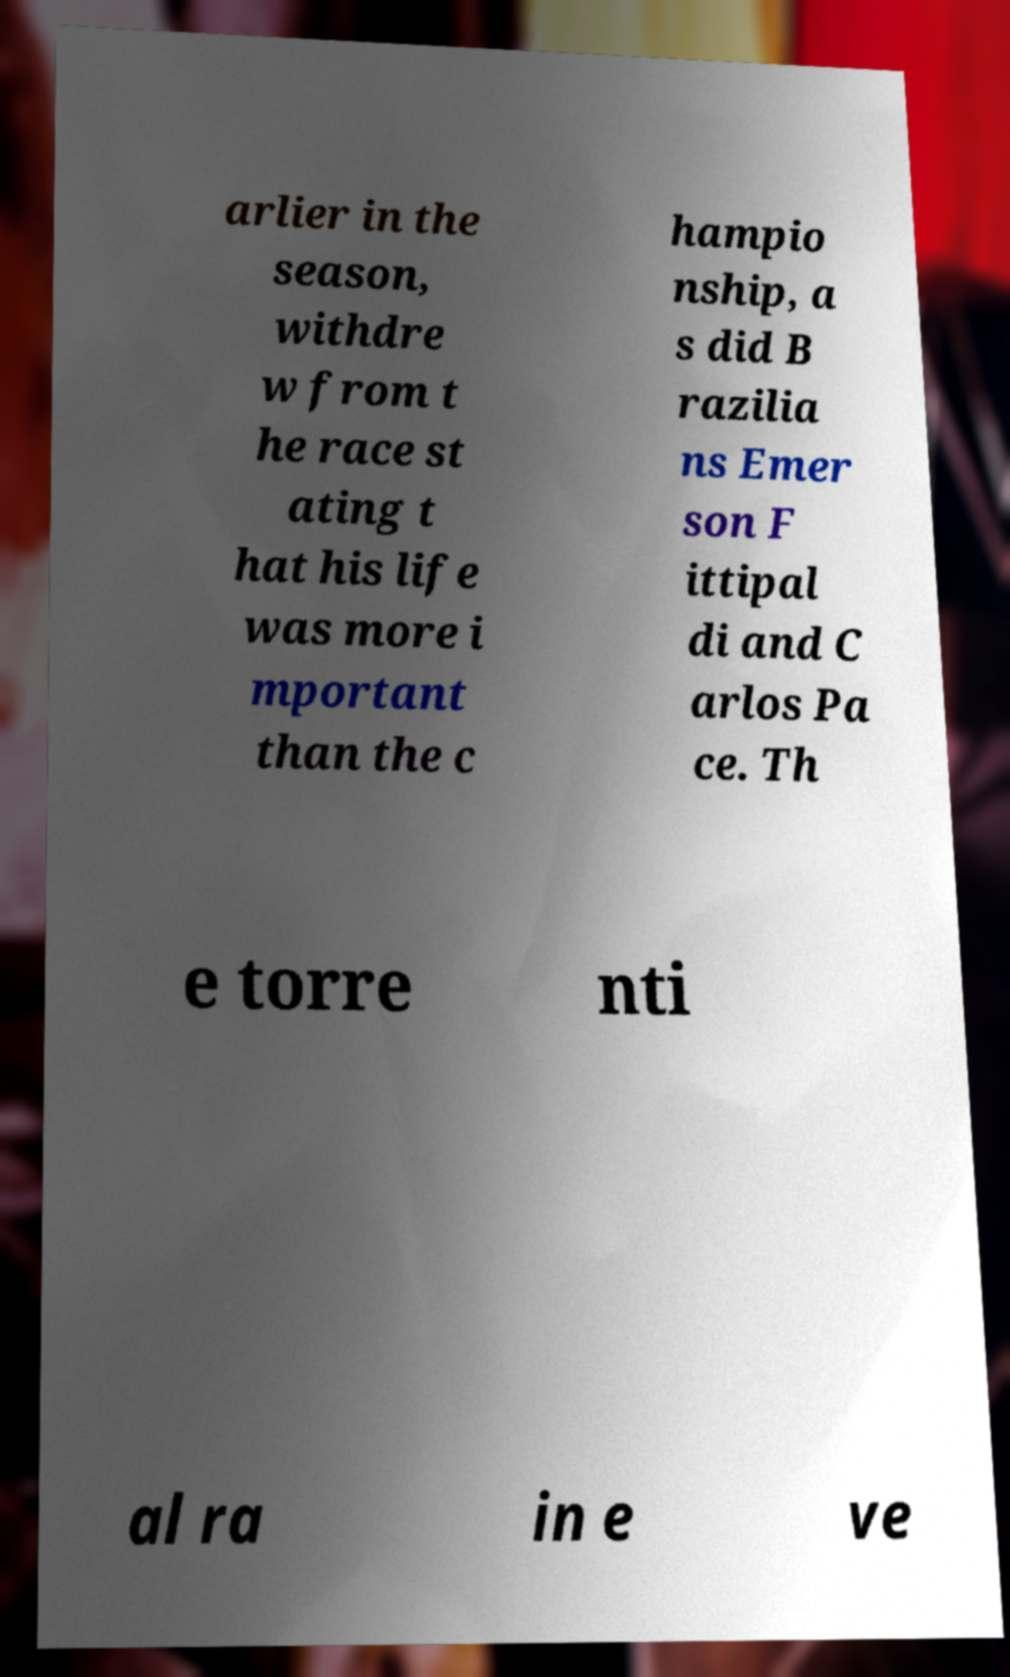Can you read and provide the text displayed in the image?This photo seems to have some interesting text. Can you extract and type it out for me? arlier in the season, withdre w from t he race st ating t hat his life was more i mportant than the c hampio nship, a s did B razilia ns Emer son F ittipal di and C arlos Pa ce. Th e torre nti al ra in e ve 